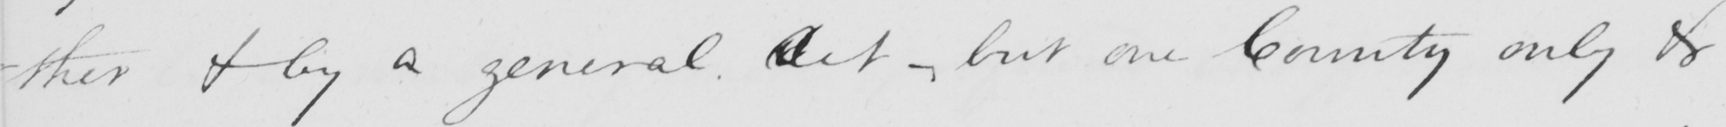Can you read and transcribe this handwriting? -ther & by a general Act , but one County only & 